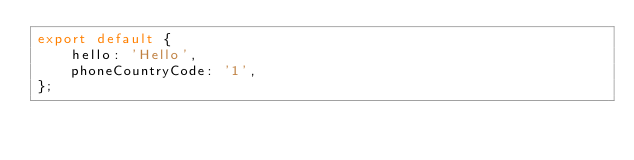<code> <loc_0><loc_0><loc_500><loc_500><_JavaScript_>export default {
    hello: 'Hello',
    phoneCountryCode: '1',
};
</code> 